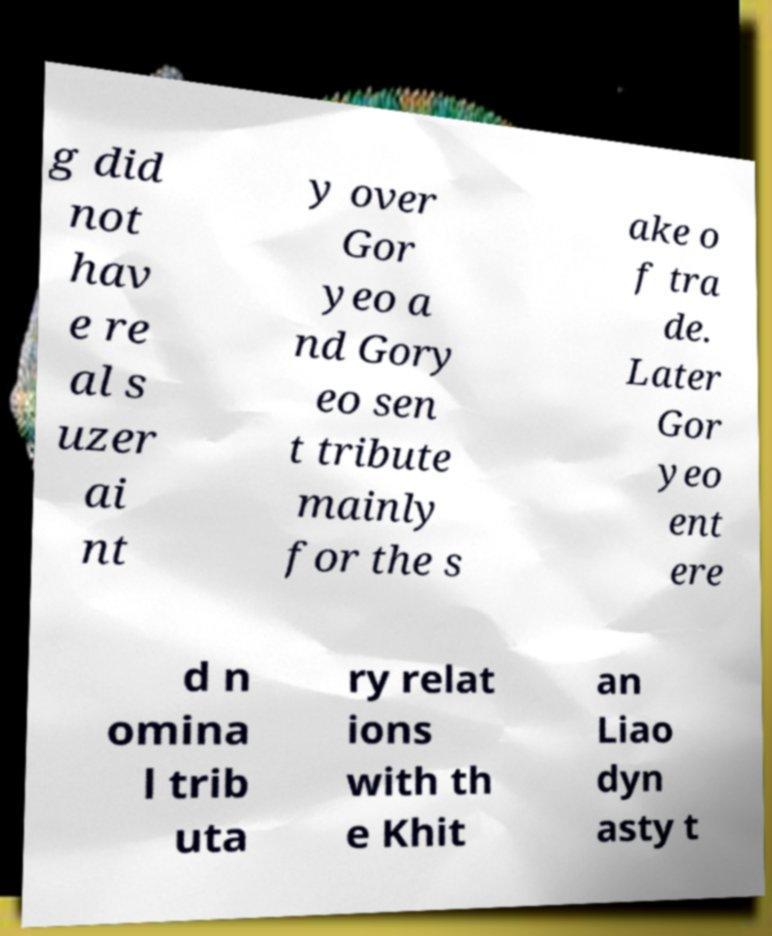I need the written content from this picture converted into text. Can you do that? g did not hav e re al s uzer ai nt y over Gor yeo a nd Gory eo sen t tribute mainly for the s ake o f tra de. Later Gor yeo ent ere d n omina l trib uta ry relat ions with th e Khit an Liao dyn asty t 